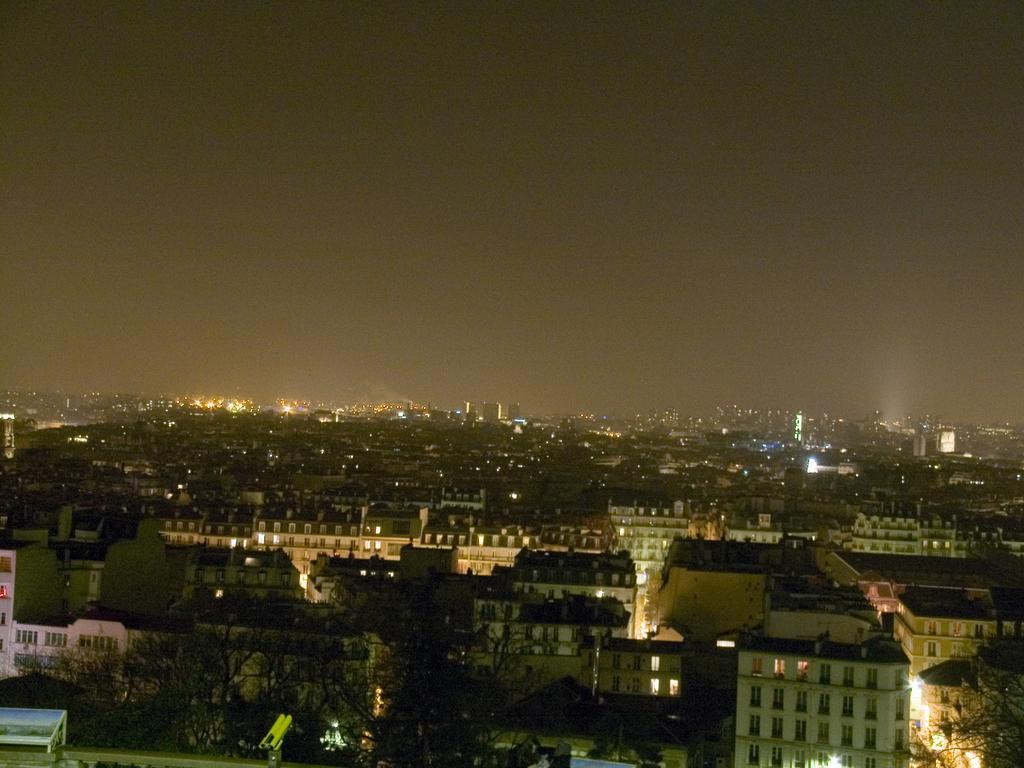In one or two sentences, can you explain what this image depicts? This image is an aerial view. In this image we can see many buildings and trees. We can see lights. At the top there is sky. 